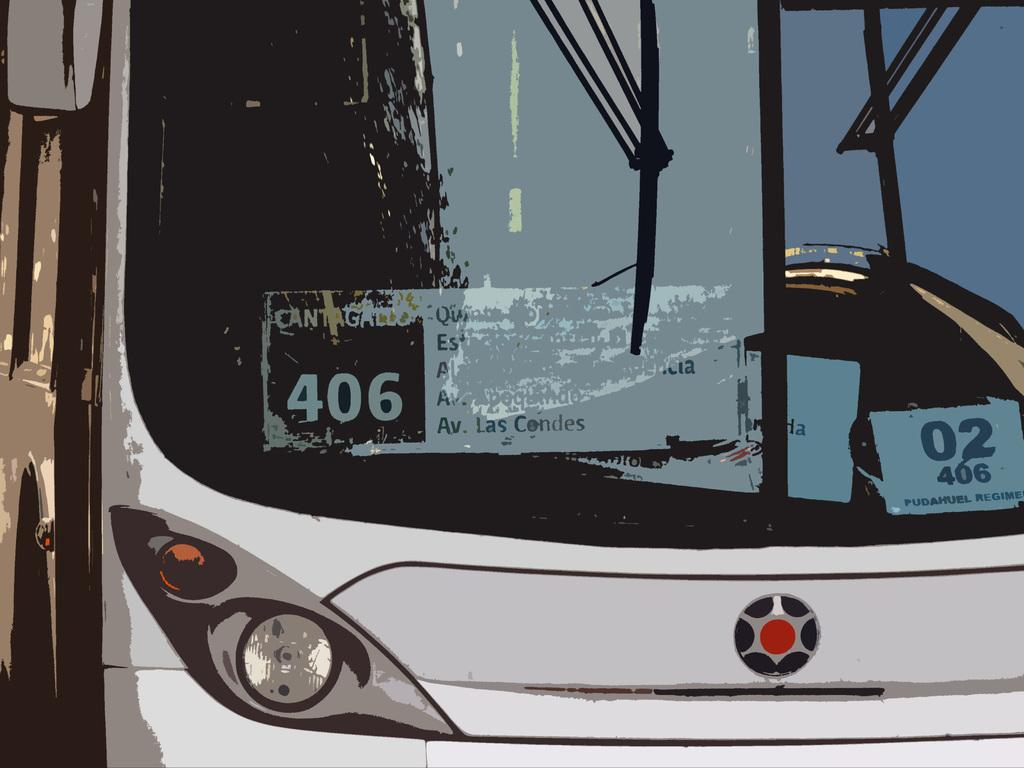What type of object is in the image? There is a vehicle in the image. What colors can be seen on the vehicle? The vehicle is white and black in color. What features does the vehicle have? The vehicle has a windshield, a side mirror, and wipers. What can be found inside the vehicle? There are boards visible inside the vehicle. What degree of difficulty is the love advertisement in the image? There is no love advertisement present in the image, so it is not possible to determine its degree of difficulty. 